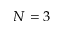Convert formula to latex. <formula><loc_0><loc_0><loc_500><loc_500>N = 3</formula> 